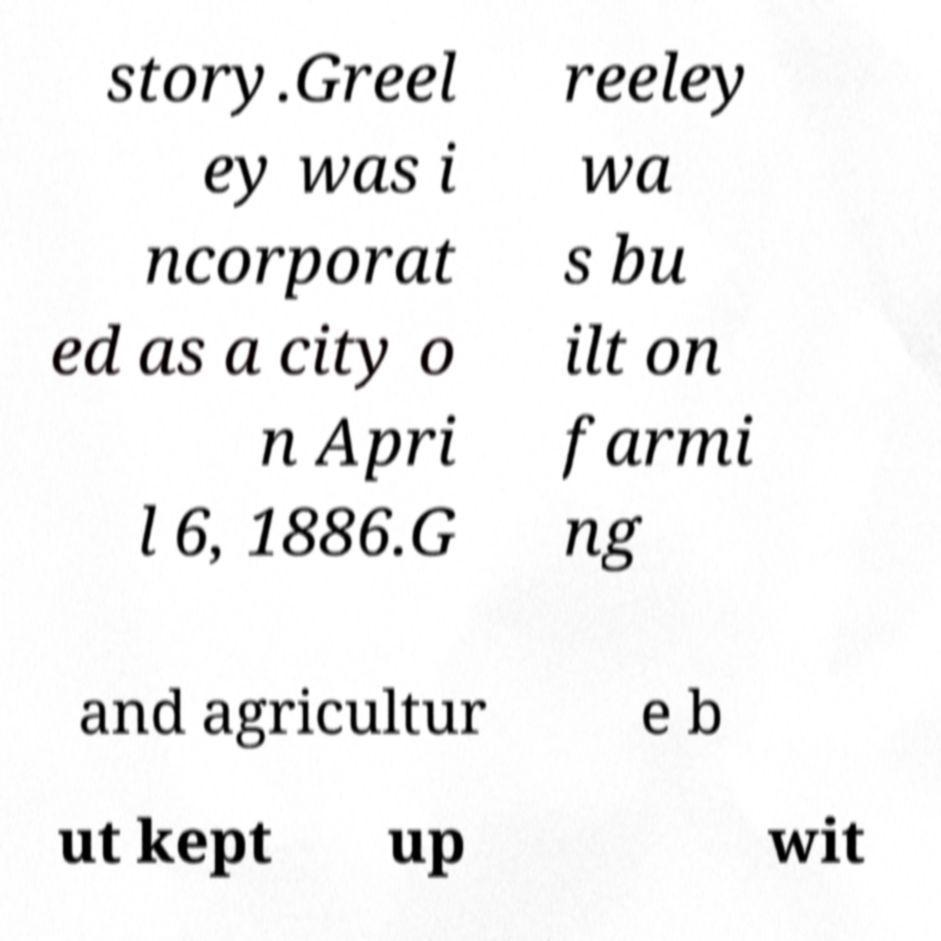Please identify and transcribe the text found in this image. story.Greel ey was i ncorporat ed as a city o n Apri l 6, 1886.G reeley wa s bu ilt on farmi ng and agricultur e b ut kept up wit 